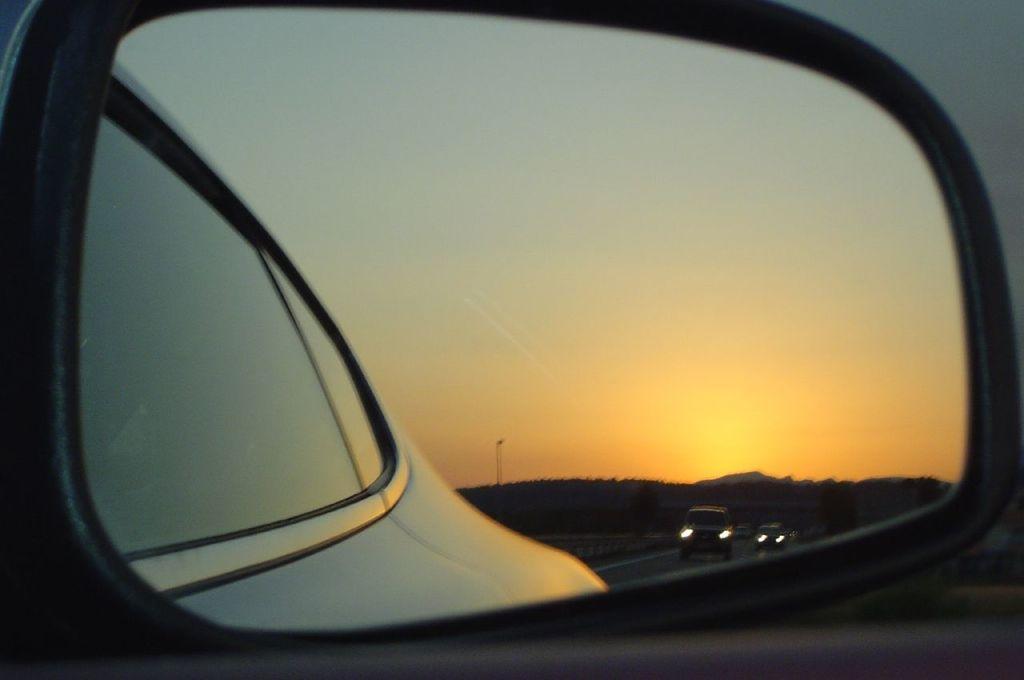Can you describe this image briefly? There is a car mirror in the foreground area, where we can see trees, vehicles, pole and sky. 